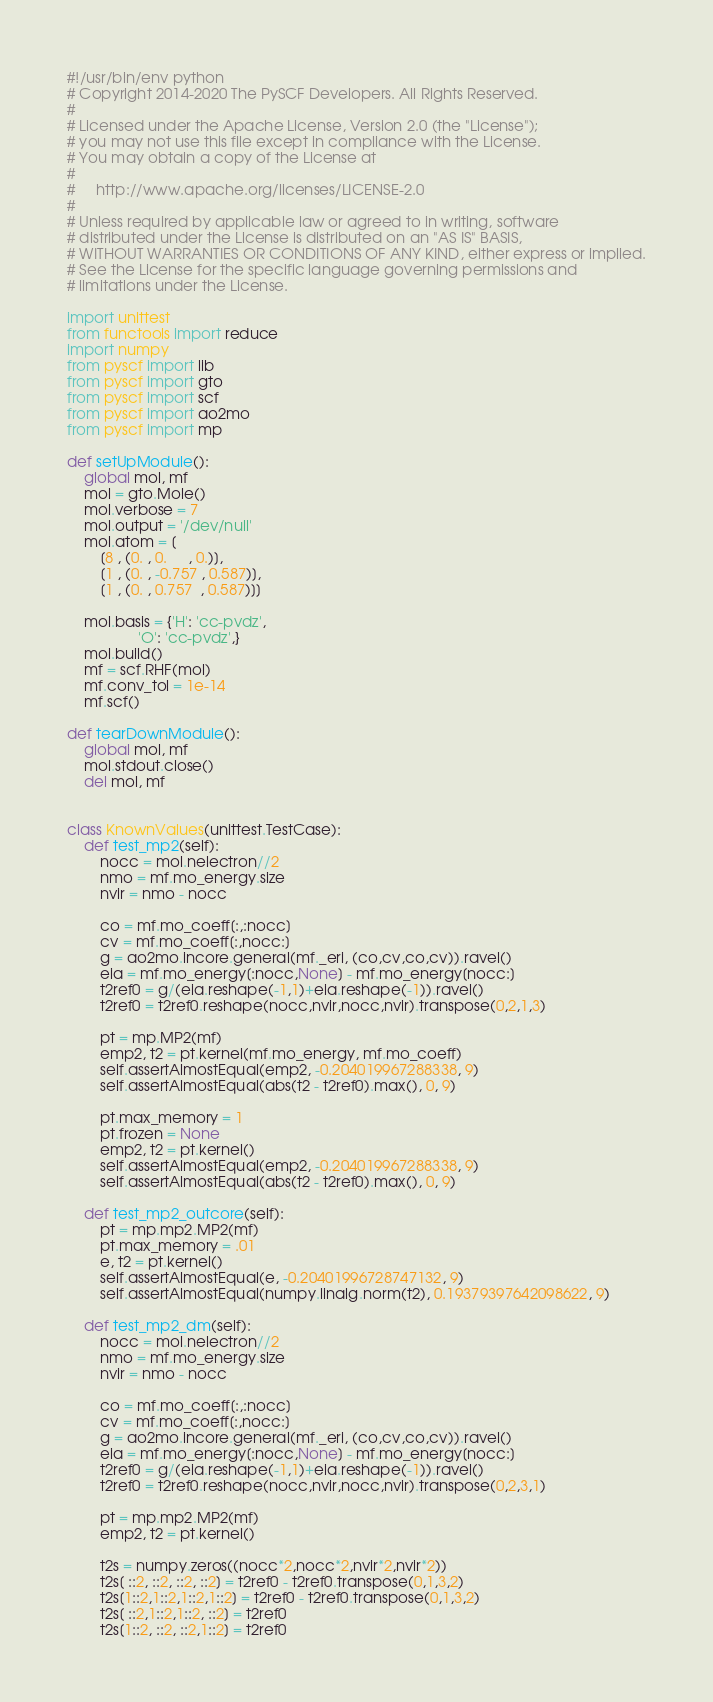<code> <loc_0><loc_0><loc_500><loc_500><_Python_>#!/usr/bin/env python
# Copyright 2014-2020 The PySCF Developers. All Rights Reserved.
#
# Licensed under the Apache License, Version 2.0 (the "License");
# you may not use this file except in compliance with the License.
# You may obtain a copy of the License at
#
#     http://www.apache.org/licenses/LICENSE-2.0
#
# Unless required by applicable law or agreed to in writing, software
# distributed under the License is distributed on an "AS IS" BASIS,
# WITHOUT WARRANTIES OR CONDITIONS OF ANY KIND, either express or implied.
# See the License for the specific language governing permissions and
# limitations under the License.

import unittest
from functools import reduce
import numpy
from pyscf import lib
from pyscf import gto
from pyscf import scf
from pyscf import ao2mo
from pyscf import mp

def setUpModule():
    global mol, mf
    mol = gto.Mole()
    mol.verbose = 7
    mol.output = '/dev/null'
    mol.atom = [
        [8 , (0. , 0.     , 0.)],
        [1 , (0. , -0.757 , 0.587)],
        [1 , (0. , 0.757  , 0.587)]]

    mol.basis = {'H': 'cc-pvdz',
                 'O': 'cc-pvdz',}
    mol.build()
    mf = scf.RHF(mol)
    mf.conv_tol = 1e-14
    mf.scf()

def tearDownModule():
    global mol, mf
    mol.stdout.close()
    del mol, mf


class KnownValues(unittest.TestCase):
    def test_mp2(self):
        nocc = mol.nelectron//2
        nmo = mf.mo_energy.size
        nvir = nmo - nocc

        co = mf.mo_coeff[:,:nocc]
        cv = mf.mo_coeff[:,nocc:]
        g = ao2mo.incore.general(mf._eri, (co,cv,co,cv)).ravel()
        eia = mf.mo_energy[:nocc,None] - mf.mo_energy[nocc:]
        t2ref0 = g/(eia.reshape(-1,1)+eia.reshape(-1)).ravel()
        t2ref0 = t2ref0.reshape(nocc,nvir,nocc,nvir).transpose(0,2,1,3)

        pt = mp.MP2(mf)
        emp2, t2 = pt.kernel(mf.mo_energy, mf.mo_coeff)
        self.assertAlmostEqual(emp2, -0.204019967288338, 9)
        self.assertAlmostEqual(abs(t2 - t2ref0).max(), 0, 9)

        pt.max_memory = 1
        pt.frozen = None
        emp2, t2 = pt.kernel()
        self.assertAlmostEqual(emp2, -0.204019967288338, 9)
        self.assertAlmostEqual(abs(t2 - t2ref0).max(), 0, 9)

    def test_mp2_outcore(self):
        pt = mp.mp2.MP2(mf)
        pt.max_memory = .01
        e, t2 = pt.kernel()
        self.assertAlmostEqual(e, -0.20401996728747132, 9)
        self.assertAlmostEqual(numpy.linalg.norm(t2), 0.19379397642098622, 9)

    def test_mp2_dm(self):
        nocc = mol.nelectron//2
        nmo = mf.mo_energy.size
        nvir = nmo - nocc

        co = mf.mo_coeff[:,:nocc]
        cv = mf.mo_coeff[:,nocc:]
        g = ao2mo.incore.general(mf._eri, (co,cv,co,cv)).ravel()
        eia = mf.mo_energy[:nocc,None] - mf.mo_energy[nocc:]
        t2ref0 = g/(eia.reshape(-1,1)+eia.reshape(-1)).ravel()
        t2ref0 = t2ref0.reshape(nocc,nvir,nocc,nvir).transpose(0,2,3,1)

        pt = mp.mp2.MP2(mf)
        emp2, t2 = pt.kernel()

        t2s = numpy.zeros((nocc*2,nocc*2,nvir*2,nvir*2))
        t2s[ ::2, ::2, ::2, ::2] = t2ref0 - t2ref0.transpose(0,1,3,2)
        t2s[1::2,1::2,1::2,1::2] = t2ref0 - t2ref0.transpose(0,1,3,2)
        t2s[ ::2,1::2,1::2, ::2] = t2ref0
        t2s[1::2, ::2, ::2,1::2] = t2ref0</code> 